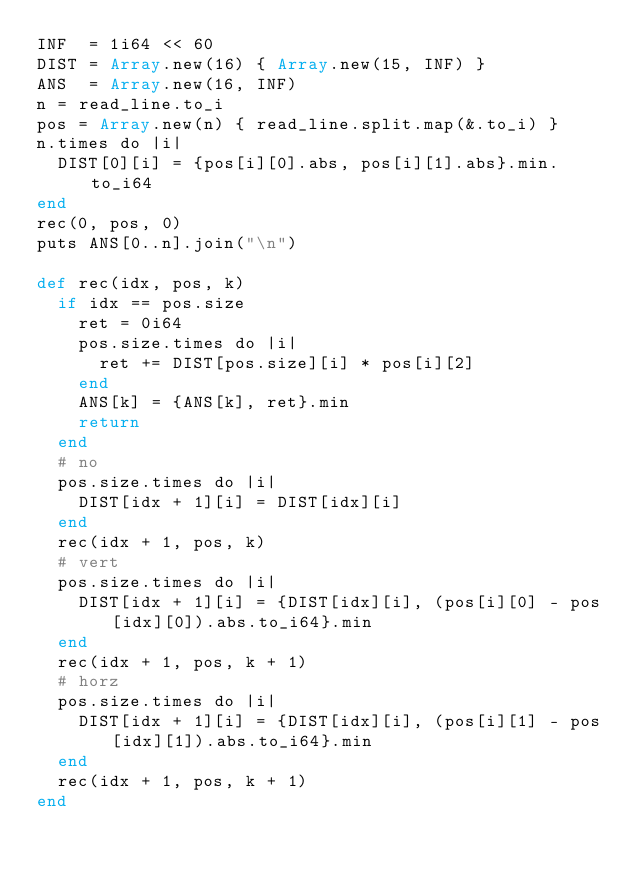<code> <loc_0><loc_0><loc_500><loc_500><_Crystal_>INF  = 1i64 << 60
DIST = Array.new(16) { Array.new(15, INF) }
ANS  = Array.new(16, INF)
n = read_line.to_i
pos = Array.new(n) { read_line.split.map(&.to_i) }
n.times do |i|
  DIST[0][i] = {pos[i][0].abs, pos[i][1].abs}.min.to_i64
end
rec(0, pos, 0)
puts ANS[0..n].join("\n")

def rec(idx, pos, k)
  if idx == pos.size
    ret = 0i64
    pos.size.times do |i|
      ret += DIST[pos.size][i] * pos[i][2]
    end
    ANS[k] = {ANS[k], ret}.min
    return
  end
  # no
  pos.size.times do |i|
    DIST[idx + 1][i] = DIST[idx][i]
  end
  rec(idx + 1, pos, k)
  # vert
  pos.size.times do |i|
    DIST[idx + 1][i] = {DIST[idx][i], (pos[i][0] - pos[idx][0]).abs.to_i64}.min
  end
  rec(idx + 1, pos, k + 1)
  # horz
  pos.size.times do |i|
    DIST[idx + 1][i] = {DIST[idx][i], (pos[i][1] - pos[idx][1]).abs.to_i64}.min
  end
  rec(idx + 1, pos, k + 1)
end
</code> 